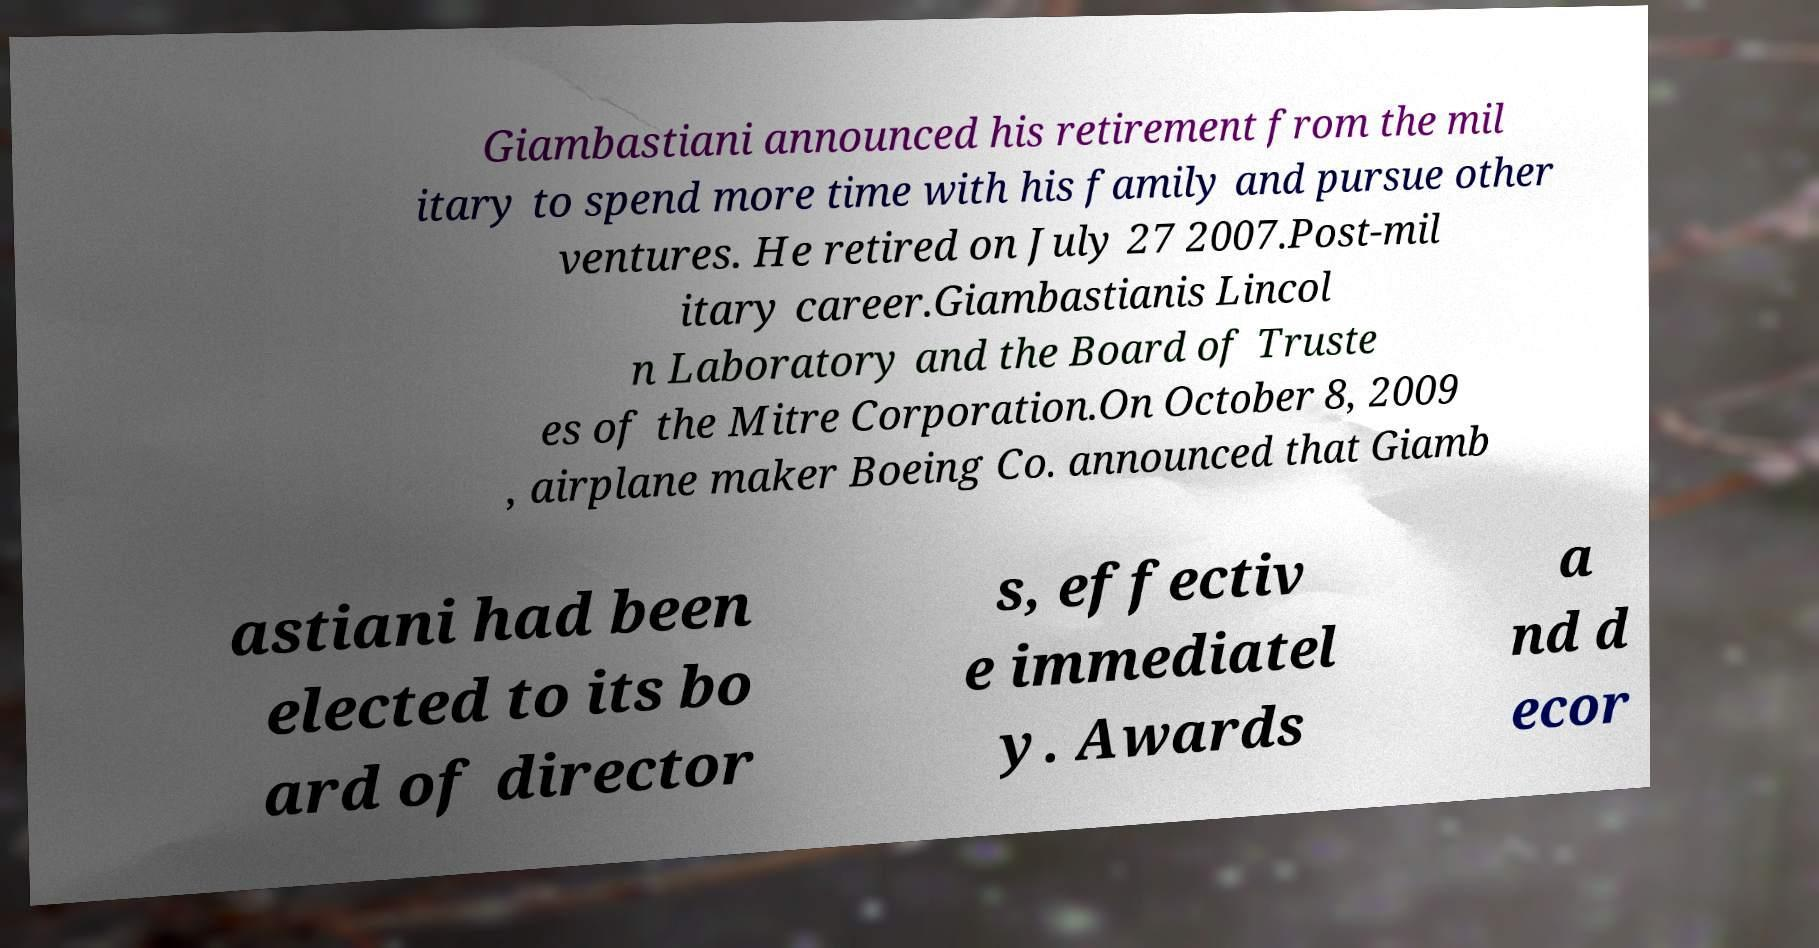Could you assist in decoding the text presented in this image and type it out clearly? Giambastiani announced his retirement from the mil itary to spend more time with his family and pursue other ventures. He retired on July 27 2007.Post-mil itary career.Giambastianis Lincol n Laboratory and the Board of Truste es of the Mitre Corporation.On October 8, 2009 , airplane maker Boeing Co. announced that Giamb astiani had been elected to its bo ard of director s, effectiv e immediatel y. Awards a nd d ecor 